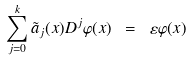<formula> <loc_0><loc_0><loc_500><loc_500>\sum _ { j = 0 } ^ { k } \tilde { a } _ { j } ( x ) D ^ { j } \varphi ( x ) \ = \ \varepsilon \varphi ( x )</formula> 